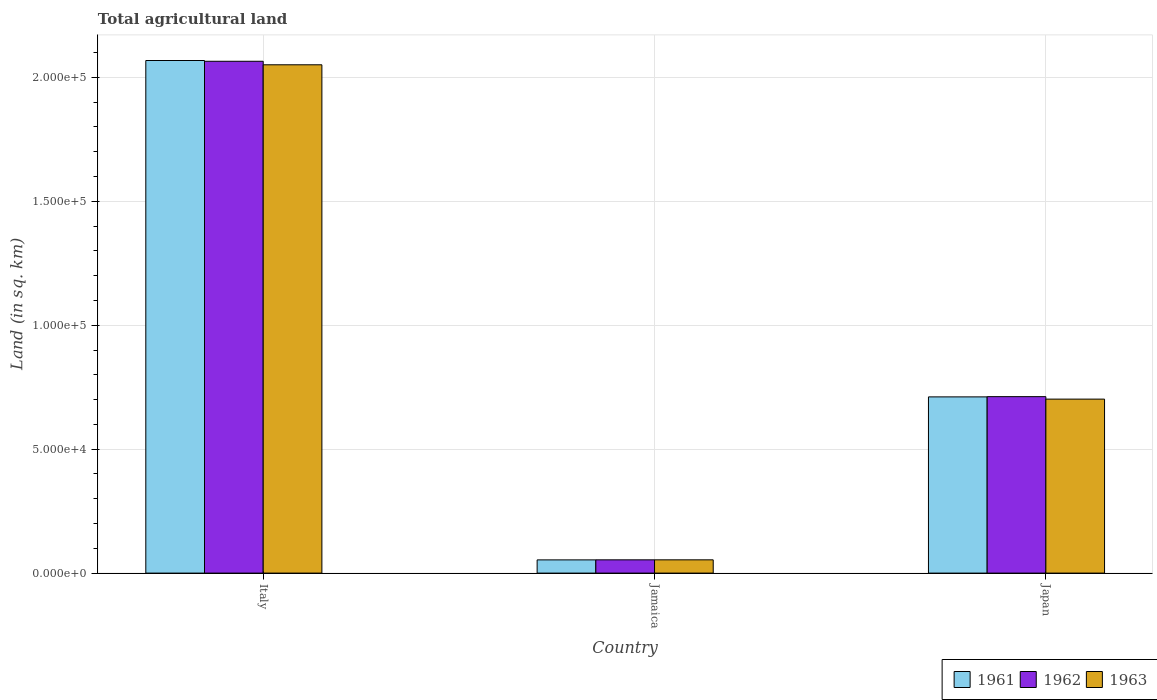How many groups of bars are there?
Your answer should be compact. 3. Are the number of bars on each tick of the X-axis equal?
Your answer should be compact. Yes. How many bars are there on the 3rd tick from the right?
Make the answer very short. 3. What is the label of the 2nd group of bars from the left?
Make the answer very short. Jamaica. What is the total agricultural land in 1962 in Italy?
Give a very brief answer. 2.07e+05. Across all countries, what is the maximum total agricultural land in 1961?
Your answer should be very brief. 2.07e+05. Across all countries, what is the minimum total agricultural land in 1963?
Give a very brief answer. 5350. In which country was the total agricultural land in 1961 maximum?
Provide a succinct answer. Italy. In which country was the total agricultural land in 1962 minimum?
Ensure brevity in your answer.  Jamaica. What is the total total agricultural land in 1962 in the graph?
Your answer should be very brief. 2.83e+05. What is the difference between the total agricultural land in 1962 in Jamaica and that in Japan?
Make the answer very short. -6.58e+04. What is the difference between the total agricultural land in 1962 in Italy and the total agricultural land in 1963 in Jamaica?
Offer a very short reply. 2.01e+05. What is the average total agricultural land in 1963 per country?
Give a very brief answer. 9.36e+04. What is the difference between the total agricultural land of/in 1963 and total agricultural land of/in 1962 in Italy?
Provide a succinct answer. -1420. In how many countries, is the total agricultural land in 1963 greater than 10000 sq.km?
Ensure brevity in your answer.  2. What is the ratio of the total agricultural land in 1963 in Italy to that in Japan?
Keep it short and to the point. 2.92. Is the difference between the total agricultural land in 1963 in Jamaica and Japan greater than the difference between the total agricultural land in 1962 in Jamaica and Japan?
Ensure brevity in your answer.  Yes. What is the difference between the highest and the second highest total agricultural land in 1961?
Provide a short and direct response. -6.58e+04. What is the difference between the highest and the lowest total agricultural land in 1962?
Your answer should be compact. 2.01e+05. Is the sum of the total agricultural land in 1962 in Jamaica and Japan greater than the maximum total agricultural land in 1961 across all countries?
Provide a succinct answer. No. What does the 2nd bar from the left in Italy represents?
Your response must be concise. 1962. Is it the case that in every country, the sum of the total agricultural land in 1962 and total agricultural land in 1961 is greater than the total agricultural land in 1963?
Ensure brevity in your answer.  Yes. How many bars are there?
Your response must be concise. 9. How many countries are there in the graph?
Your response must be concise. 3. Are the values on the major ticks of Y-axis written in scientific E-notation?
Keep it short and to the point. Yes. Does the graph contain grids?
Your response must be concise. Yes. Where does the legend appear in the graph?
Make the answer very short. Bottom right. How many legend labels are there?
Your answer should be compact. 3. How are the legend labels stacked?
Provide a succinct answer. Horizontal. What is the title of the graph?
Keep it short and to the point. Total agricultural land. What is the label or title of the Y-axis?
Provide a succinct answer. Land (in sq. km). What is the Land (in sq. km) in 1961 in Italy?
Ensure brevity in your answer.  2.07e+05. What is the Land (in sq. km) of 1962 in Italy?
Your response must be concise. 2.07e+05. What is the Land (in sq. km) of 1963 in Italy?
Ensure brevity in your answer.  2.05e+05. What is the Land (in sq. km) in 1961 in Jamaica?
Provide a short and direct response. 5330. What is the Land (in sq. km) of 1962 in Jamaica?
Your answer should be compact. 5350. What is the Land (in sq. km) in 1963 in Jamaica?
Your response must be concise. 5350. What is the Land (in sq. km) of 1961 in Japan?
Provide a succinct answer. 7.11e+04. What is the Land (in sq. km) in 1962 in Japan?
Make the answer very short. 7.12e+04. What is the Land (in sq. km) in 1963 in Japan?
Provide a succinct answer. 7.02e+04. Across all countries, what is the maximum Land (in sq. km) in 1961?
Offer a very short reply. 2.07e+05. Across all countries, what is the maximum Land (in sq. km) in 1962?
Make the answer very short. 2.07e+05. Across all countries, what is the maximum Land (in sq. km) of 1963?
Provide a short and direct response. 2.05e+05. Across all countries, what is the minimum Land (in sq. km) of 1961?
Your response must be concise. 5330. Across all countries, what is the minimum Land (in sq. km) of 1962?
Keep it short and to the point. 5350. Across all countries, what is the minimum Land (in sq. km) in 1963?
Make the answer very short. 5350. What is the total Land (in sq. km) in 1961 in the graph?
Your answer should be compact. 2.83e+05. What is the total Land (in sq. km) in 1962 in the graph?
Offer a terse response. 2.83e+05. What is the total Land (in sq. km) of 1963 in the graph?
Provide a short and direct response. 2.81e+05. What is the difference between the Land (in sq. km) of 1961 in Italy and that in Jamaica?
Provide a succinct answer. 2.02e+05. What is the difference between the Land (in sq. km) in 1962 in Italy and that in Jamaica?
Make the answer very short. 2.01e+05. What is the difference between the Land (in sq. km) of 1963 in Italy and that in Jamaica?
Offer a terse response. 2.00e+05. What is the difference between the Land (in sq. km) of 1961 in Italy and that in Japan?
Ensure brevity in your answer.  1.36e+05. What is the difference between the Land (in sq. km) of 1962 in Italy and that in Japan?
Offer a very short reply. 1.35e+05. What is the difference between the Land (in sq. km) in 1963 in Italy and that in Japan?
Provide a succinct answer. 1.35e+05. What is the difference between the Land (in sq. km) of 1961 in Jamaica and that in Japan?
Your answer should be compact. -6.58e+04. What is the difference between the Land (in sq. km) of 1962 in Jamaica and that in Japan?
Give a very brief answer. -6.58e+04. What is the difference between the Land (in sq. km) of 1963 in Jamaica and that in Japan?
Make the answer very short. -6.48e+04. What is the difference between the Land (in sq. km) in 1961 in Italy and the Land (in sq. km) in 1962 in Jamaica?
Keep it short and to the point. 2.01e+05. What is the difference between the Land (in sq. km) of 1961 in Italy and the Land (in sq. km) of 1963 in Jamaica?
Give a very brief answer. 2.01e+05. What is the difference between the Land (in sq. km) of 1962 in Italy and the Land (in sq. km) of 1963 in Jamaica?
Ensure brevity in your answer.  2.01e+05. What is the difference between the Land (in sq. km) of 1961 in Italy and the Land (in sq. km) of 1962 in Japan?
Provide a succinct answer. 1.36e+05. What is the difference between the Land (in sq. km) in 1961 in Italy and the Land (in sq. km) in 1963 in Japan?
Your answer should be very brief. 1.37e+05. What is the difference between the Land (in sq. km) in 1962 in Italy and the Land (in sq. km) in 1963 in Japan?
Make the answer very short. 1.36e+05. What is the difference between the Land (in sq. km) of 1961 in Jamaica and the Land (in sq. km) of 1962 in Japan?
Provide a short and direct response. -6.59e+04. What is the difference between the Land (in sq. km) of 1961 in Jamaica and the Land (in sq. km) of 1963 in Japan?
Offer a terse response. -6.49e+04. What is the difference between the Land (in sq. km) of 1962 in Jamaica and the Land (in sq. km) of 1963 in Japan?
Your answer should be compact. -6.48e+04. What is the average Land (in sq. km) in 1961 per country?
Offer a very short reply. 9.44e+04. What is the average Land (in sq. km) of 1962 per country?
Make the answer very short. 9.44e+04. What is the average Land (in sq. km) of 1963 per country?
Offer a very short reply. 9.36e+04. What is the difference between the Land (in sq. km) of 1961 and Land (in sq. km) of 1962 in Italy?
Make the answer very short. 310. What is the difference between the Land (in sq. km) of 1961 and Land (in sq. km) of 1963 in Italy?
Offer a very short reply. 1730. What is the difference between the Land (in sq. km) in 1962 and Land (in sq. km) in 1963 in Italy?
Offer a terse response. 1420. What is the difference between the Land (in sq. km) in 1961 and Land (in sq. km) in 1963 in Jamaica?
Your response must be concise. -20. What is the difference between the Land (in sq. km) of 1962 and Land (in sq. km) of 1963 in Jamaica?
Give a very brief answer. 0. What is the difference between the Land (in sq. km) of 1961 and Land (in sq. km) of 1962 in Japan?
Provide a short and direct response. -100. What is the difference between the Land (in sq. km) of 1961 and Land (in sq. km) of 1963 in Japan?
Provide a short and direct response. 900. What is the ratio of the Land (in sq. km) of 1961 in Italy to that in Jamaica?
Offer a terse response. 38.8. What is the ratio of the Land (in sq. km) in 1962 in Italy to that in Jamaica?
Offer a very short reply. 38.6. What is the ratio of the Land (in sq. km) in 1963 in Italy to that in Jamaica?
Keep it short and to the point. 38.34. What is the ratio of the Land (in sq. km) of 1961 in Italy to that in Japan?
Offer a terse response. 2.91. What is the ratio of the Land (in sq. km) in 1962 in Italy to that in Japan?
Give a very brief answer. 2.9. What is the ratio of the Land (in sq. km) of 1963 in Italy to that in Japan?
Ensure brevity in your answer.  2.92. What is the ratio of the Land (in sq. km) in 1961 in Jamaica to that in Japan?
Make the answer very short. 0.07. What is the ratio of the Land (in sq. km) in 1962 in Jamaica to that in Japan?
Your response must be concise. 0.08. What is the ratio of the Land (in sq. km) in 1963 in Jamaica to that in Japan?
Your response must be concise. 0.08. What is the difference between the highest and the second highest Land (in sq. km) in 1961?
Provide a succinct answer. 1.36e+05. What is the difference between the highest and the second highest Land (in sq. km) of 1962?
Give a very brief answer. 1.35e+05. What is the difference between the highest and the second highest Land (in sq. km) of 1963?
Provide a short and direct response. 1.35e+05. What is the difference between the highest and the lowest Land (in sq. km) of 1961?
Ensure brevity in your answer.  2.02e+05. What is the difference between the highest and the lowest Land (in sq. km) of 1962?
Provide a succinct answer. 2.01e+05. What is the difference between the highest and the lowest Land (in sq. km) in 1963?
Your answer should be compact. 2.00e+05. 